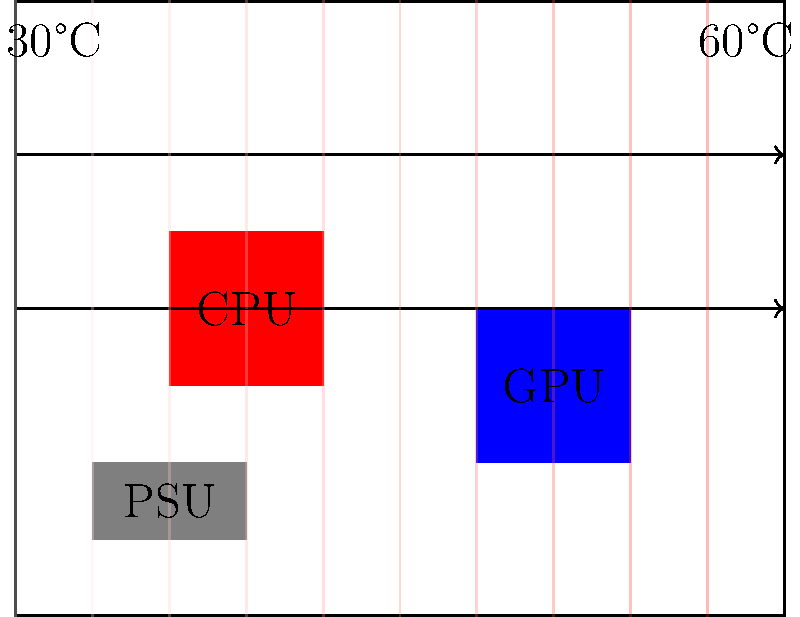In the compact computer chassis shown above, which component is likely contributing most to the overall thermal load, and what modification to the airflow pattern could potentially improve heat dissipation? To answer this question, we need to analyze the thermal gradient and airflow pattern in the given diagram:

1. Thermal gradient: The diagram shows a color gradient from left (cooler, blue) to right (hotter, red), indicating that heat is accumulating towards the right side of the chassis.

2. Component placement:
   - CPU: Located in the center, colored red (indicating high heat generation)
   - GPU: Positioned to the right, colored blue (moderate heat generation)
   - PSU: Located at the bottom left, colored gray (relatively low heat generation)

3. Airflow pattern: Two horizontal arrows indicate airflow from left to right across the chassis.

4. Heat contribution:
   - The CPU, being red and centrally located, is likely the primary heat source.
   - Its position obstructs airflow to the GPU, potentially causing heat accumulation.

5. Potential improvement:
   - Introducing vertical airflow could enhance heat dissipation, especially for the CPU.
   - This could be achieved by adding top exhaust fans or redesigning the airflow path.

Given the CPU's central position, high heat generation, and its obstruction of airflow to other components, it is likely the main contributor to the thermal load. Introducing vertical airflow could significantly improve heat dissipation by more efficiently removing heat from the CPU and allowing better airflow to the GPU.
Answer: CPU; add vertical airflow (e.g., top exhaust fans) 